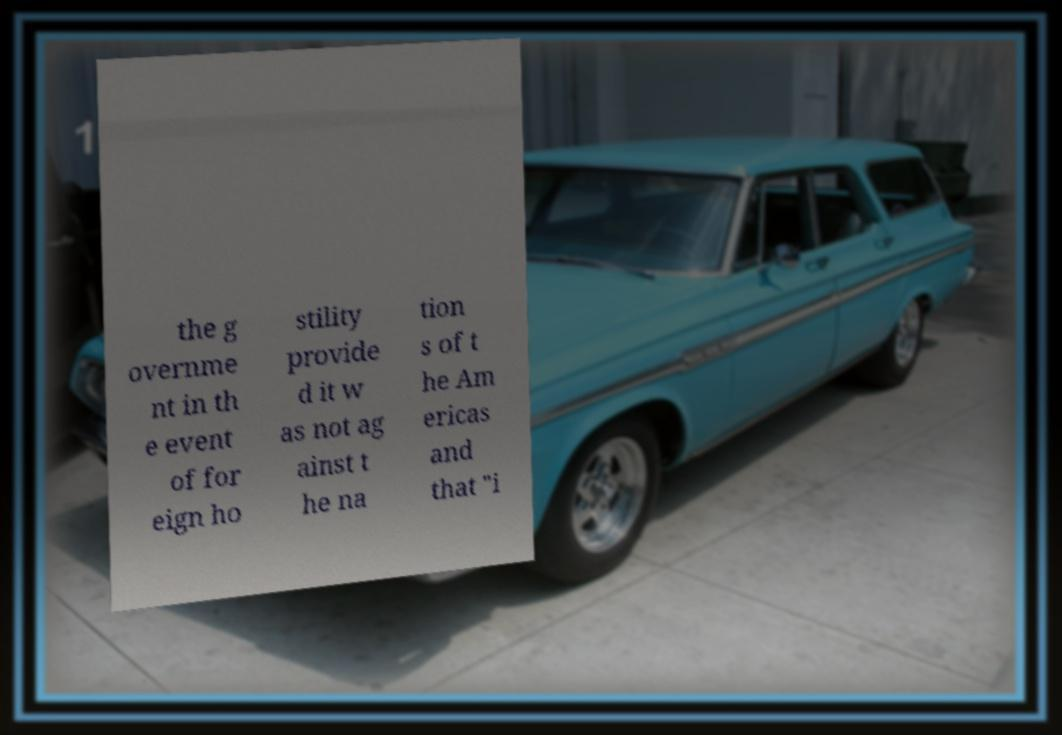Can you read and provide the text displayed in the image?This photo seems to have some interesting text. Can you extract and type it out for me? the g overnme nt in th e event of for eign ho stility provide d it w as not ag ainst t he na tion s of t he Am ericas and that "i 